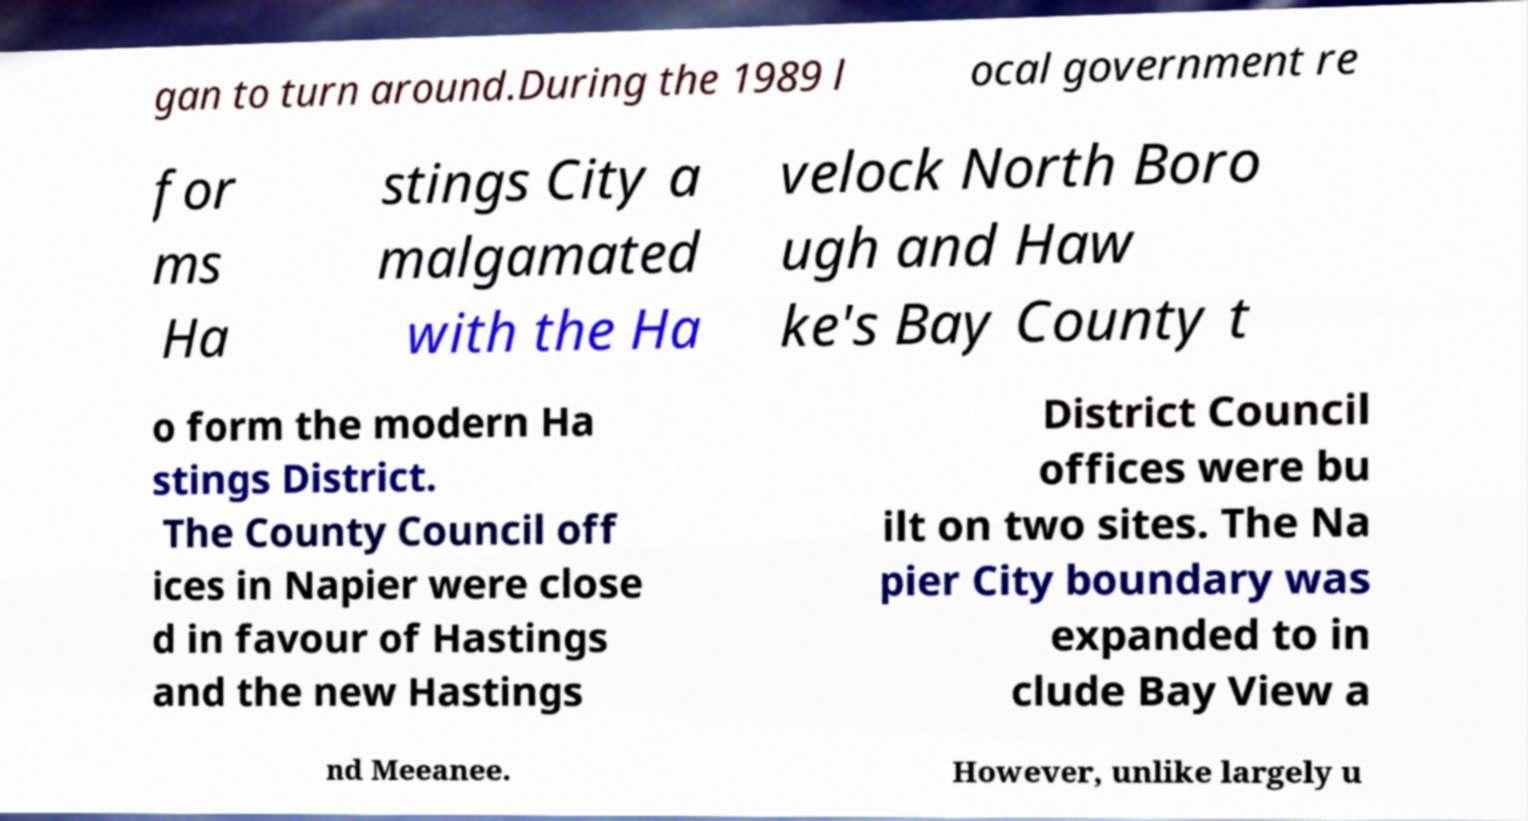Could you assist in decoding the text presented in this image and type it out clearly? gan to turn around.During the 1989 l ocal government re for ms Ha stings City a malgamated with the Ha velock North Boro ugh and Haw ke's Bay County t o form the modern Ha stings District. The County Council off ices in Napier were close d in favour of Hastings and the new Hastings District Council offices were bu ilt on two sites. The Na pier City boundary was expanded to in clude Bay View a nd Meeanee. However, unlike largely u 